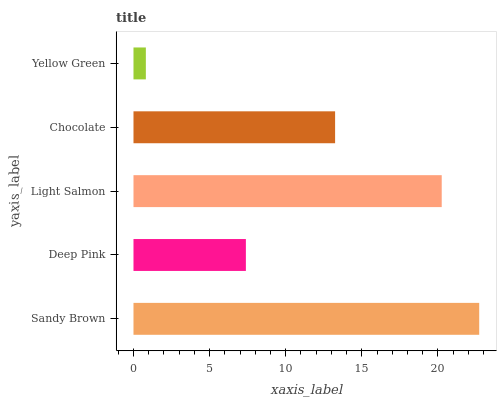Is Yellow Green the minimum?
Answer yes or no. Yes. Is Sandy Brown the maximum?
Answer yes or no. Yes. Is Deep Pink the minimum?
Answer yes or no. No. Is Deep Pink the maximum?
Answer yes or no. No. Is Sandy Brown greater than Deep Pink?
Answer yes or no. Yes. Is Deep Pink less than Sandy Brown?
Answer yes or no. Yes. Is Deep Pink greater than Sandy Brown?
Answer yes or no. No. Is Sandy Brown less than Deep Pink?
Answer yes or no. No. Is Chocolate the high median?
Answer yes or no. Yes. Is Chocolate the low median?
Answer yes or no. Yes. Is Deep Pink the high median?
Answer yes or no. No. Is Deep Pink the low median?
Answer yes or no. No. 